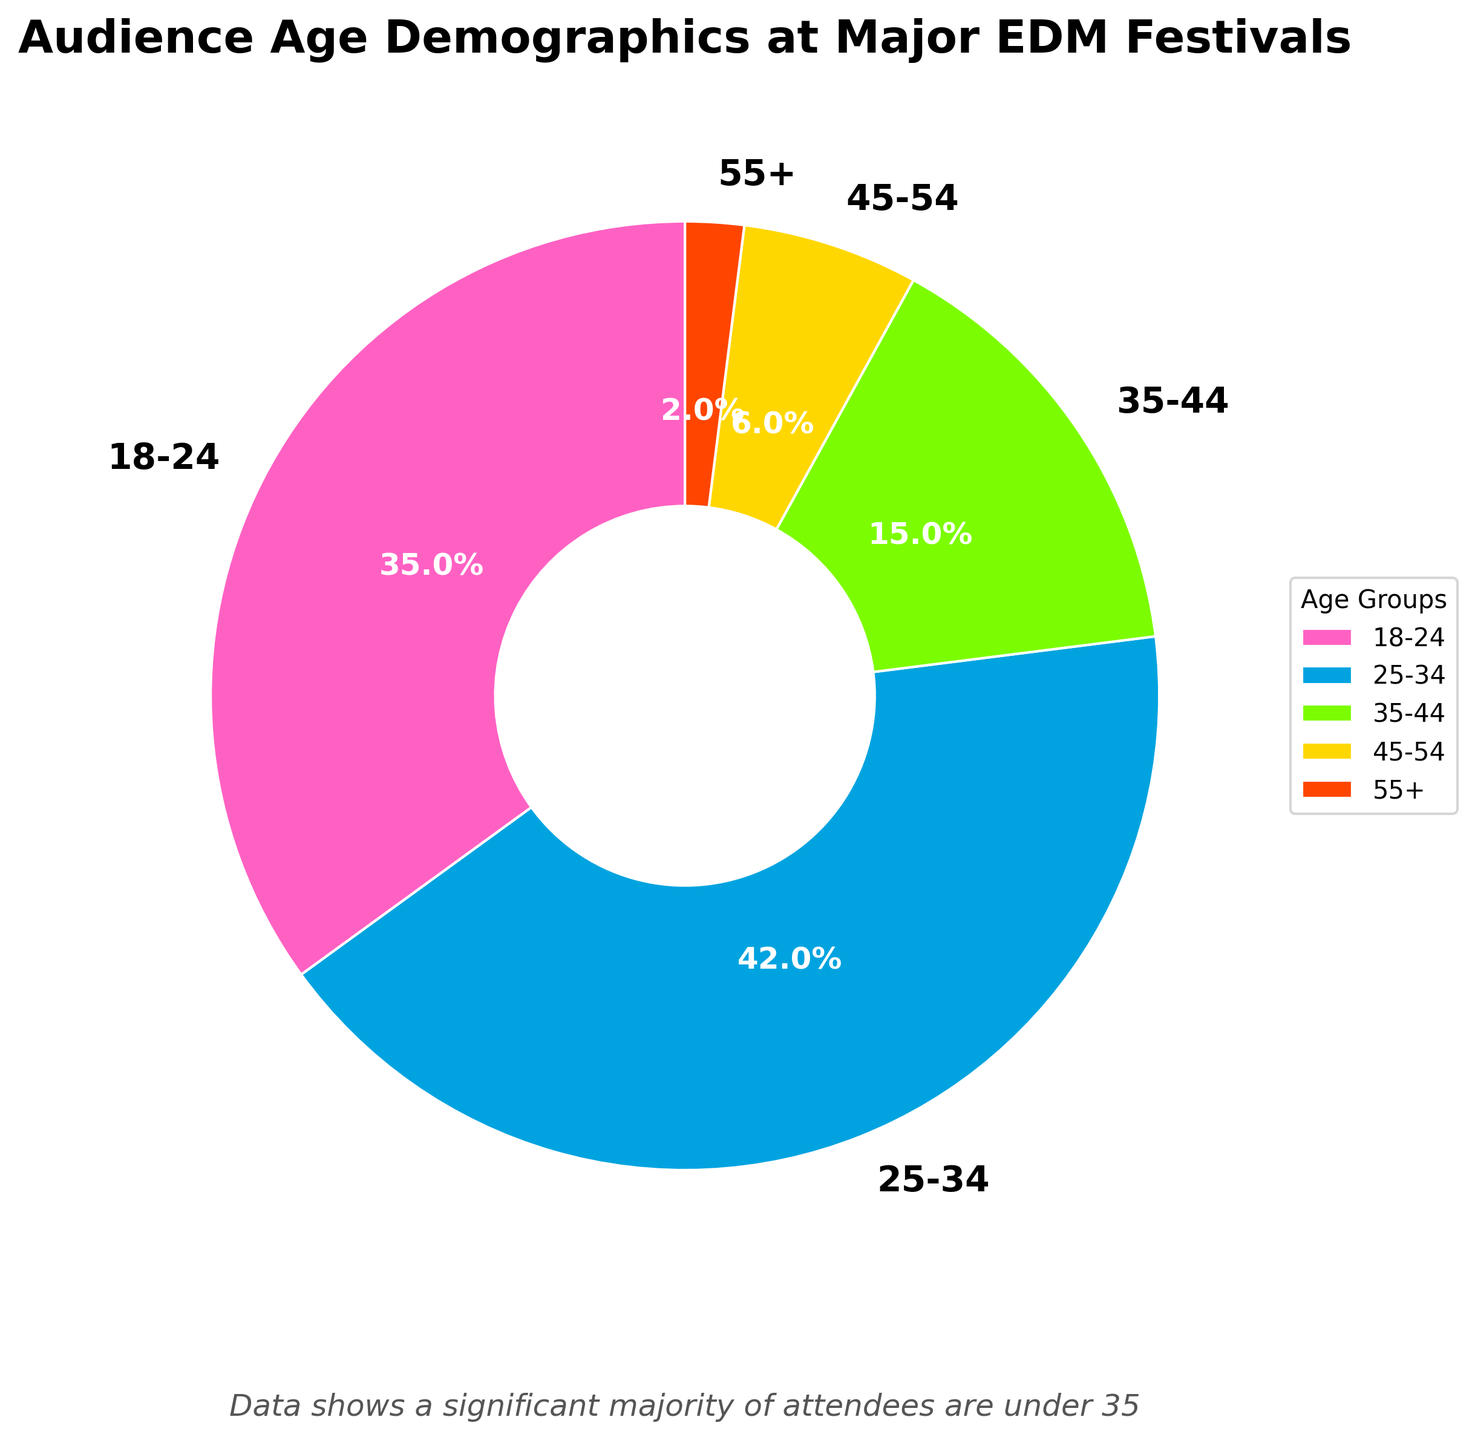What percentage of the audience is aged between 18 to 34? The age groups 18-24 and 25-34 cover the range of 18 to 34. Their percentages are 35% and 42%, respectively. Add these together: 35% + 42% = 77%.
Answer: 77% Which age group has the lowest representation at EDM festivals? From the pie chart, the 55+ age group has a representation of 2%, which is the lowest among all the age groups.
Answer: 55+ What is the combined percentage of the audience aged 35 and above? Sum the percentages of the three age groups 35-44 (15%), 45-54 (6%), and 55+ (2%): 15% + 6% + 2% = 23%.
Answer: 23% Between the 18-24 and 25-34 age groups, which one is more popular and by how much? The 25-34 age group has a percentage of 42%, whereas the 18-24 has 35%. The difference is 42% - 35% = 7%.
Answer: 25-34, by 7% How does the percentage of the 25-34 age group compare to the next two largest age groups combined? The next two largest groups are 18-24 (35%) and 35-44 (15%). Their combined percentage is 35% + 15% = 50%. The 25-34 group has 42%. Compare 42% with 50%: 50% - 42% = 8%.
Answer: 25-34 is 8% less than 18-24 and 35-44 combined What proportion of the audience is younger than 35 years old? The age groups younger than 35 are 18-24 (35%) and 25-34 (42%). Their combined percentage is 35% + 42% = 77%.
Answer: 77% Looking at the 35-44 and 45-54 age groups, which one has a higher percentage and by how much? The percentage of the 35-44 age group is 15%, and the percentage of the 45-54 age group is 6%. The difference is 15% - 6% = 9%.
Answer: 35-44, by 9% What color represents the age group with the third-highest percentage? The age group with the third-highest percentage is 35-44 with 15%. In the pie chart, this slice is colored green.
Answer: Green 